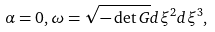<formula> <loc_0><loc_0><loc_500><loc_500>\alpha = 0 , \omega = \sqrt { - \det G } d \xi ^ { 2 } d \xi ^ { 3 } ,</formula> 